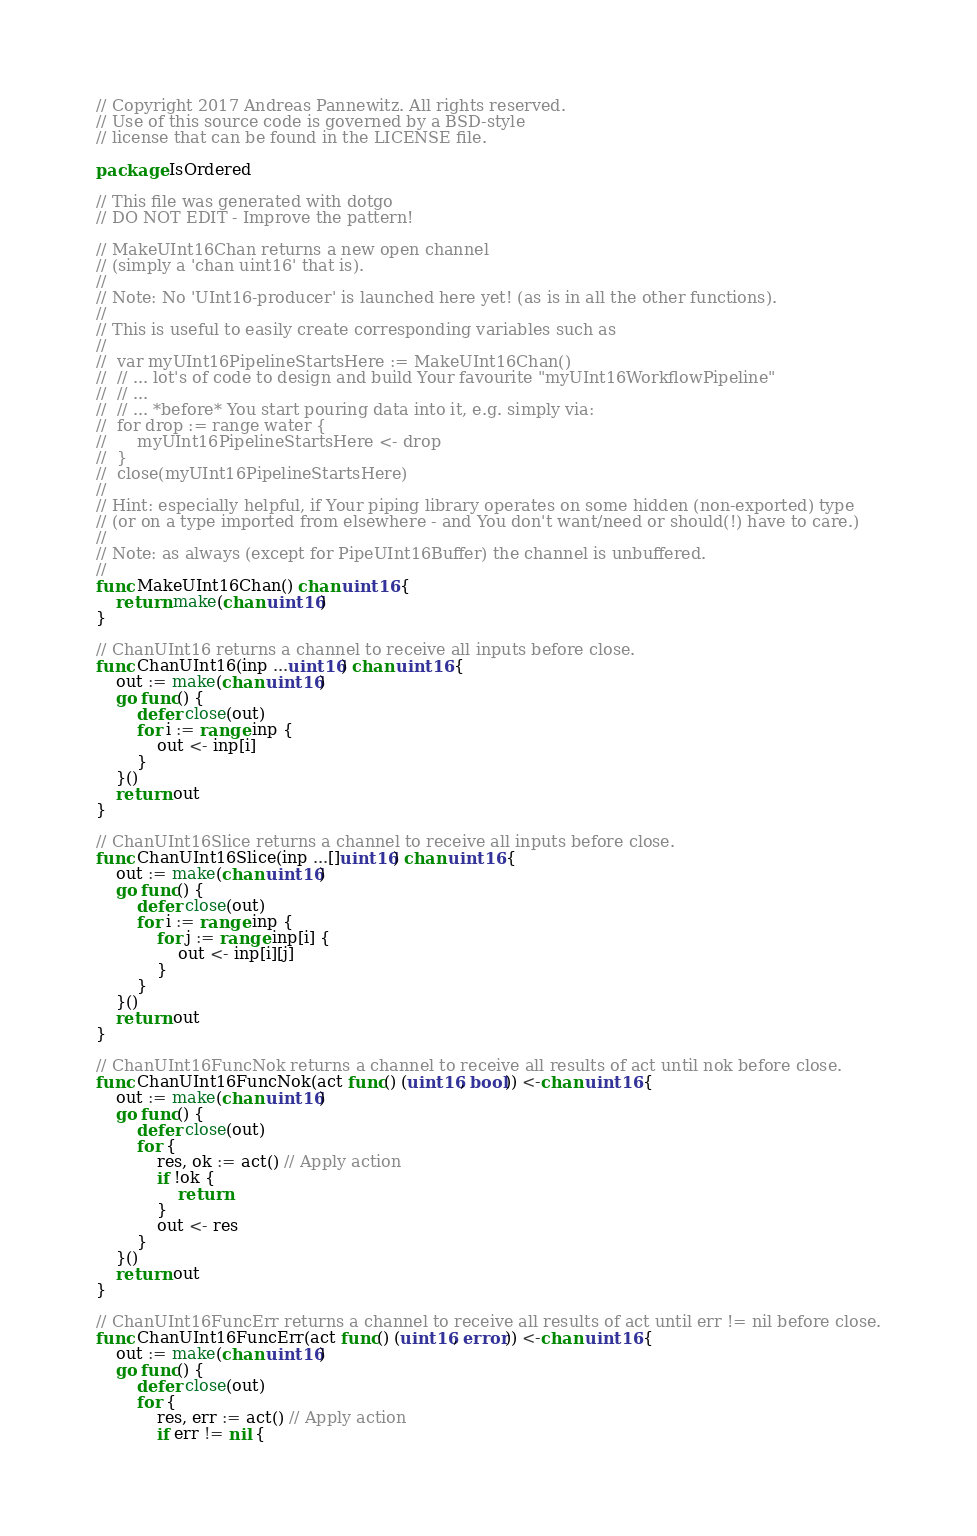Convert code to text. <code><loc_0><loc_0><loc_500><loc_500><_Go_>// Copyright 2017 Andreas Pannewitz. All rights reserved.
// Use of this source code is governed by a BSD-style
// license that can be found in the LICENSE file.

package IsOrdered

// This file was generated with dotgo
// DO NOT EDIT - Improve the pattern!

// MakeUInt16Chan returns a new open channel
// (simply a 'chan uint16' that is).
//
// Note: No 'UInt16-producer' is launched here yet! (as is in all the other functions).
//
// This is useful to easily create corresponding variables such as
//
//	var myUInt16PipelineStartsHere := MakeUInt16Chan()
//	// ... lot's of code to design and build Your favourite "myUInt16WorkflowPipeline"
//	// ...
//	// ... *before* You start pouring data into it, e.g. simply via:
//	for drop := range water {
//		myUInt16PipelineStartsHere <- drop
//	}
//	close(myUInt16PipelineStartsHere)
//
// Hint: especially helpful, if Your piping library operates on some hidden (non-exported) type
// (or on a type imported from elsewhere - and You don't want/need or should(!) have to care.)
//
// Note: as always (except for PipeUInt16Buffer) the channel is unbuffered.
//
func MakeUInt16Chan() chan uint16 {
	return make(chan uint16)
}

// ChanUInt16 returns a channel to receive all inputs before close.
func ChanUInt16(inp ...uint16) chan uint16 {
	out := make(chan uint16)
	go func() {
		defer close(out)
		for i := range inp {
			out <- inp[i]
		}
	}()
	return out
}

// ChanUInt16Slice returns a channel to receive all inputs before close.
func ChanUInt16Slice(inp ...[]uint16) chan uint16 {
	out := make(chan uint16)
	go func() {
		defer close(out)
		for i := range inp {
			for j := range inp[i] {
				out <- inp[i][j]
			}
		}
	}()
	return out
}

// ChanUInt16FuncNok returns a channel to receive all results of act until nok before close.
func ChanUInt16FuncNok(act func() (uint16, bool)) <-chan uint16 {
	out := make(chan uint16)
	go func() {
		defer close(out)
		for {
			res, ok := act() // Apply action
			if !ok {
				return
			}
			out <- res
		}
	}()
	return out
}

// ChanUInt16FuncErr returns a channel to receive all results of act until err != nil before close.
func ChanUInt16FuncErr(act func() (uint16, error)) <-chan uint16 {
	out := make(chan uint16)
	go func() {
		defer close(out)
		for {
			res, err := act() // Apply action
			if err != nil {</code> 